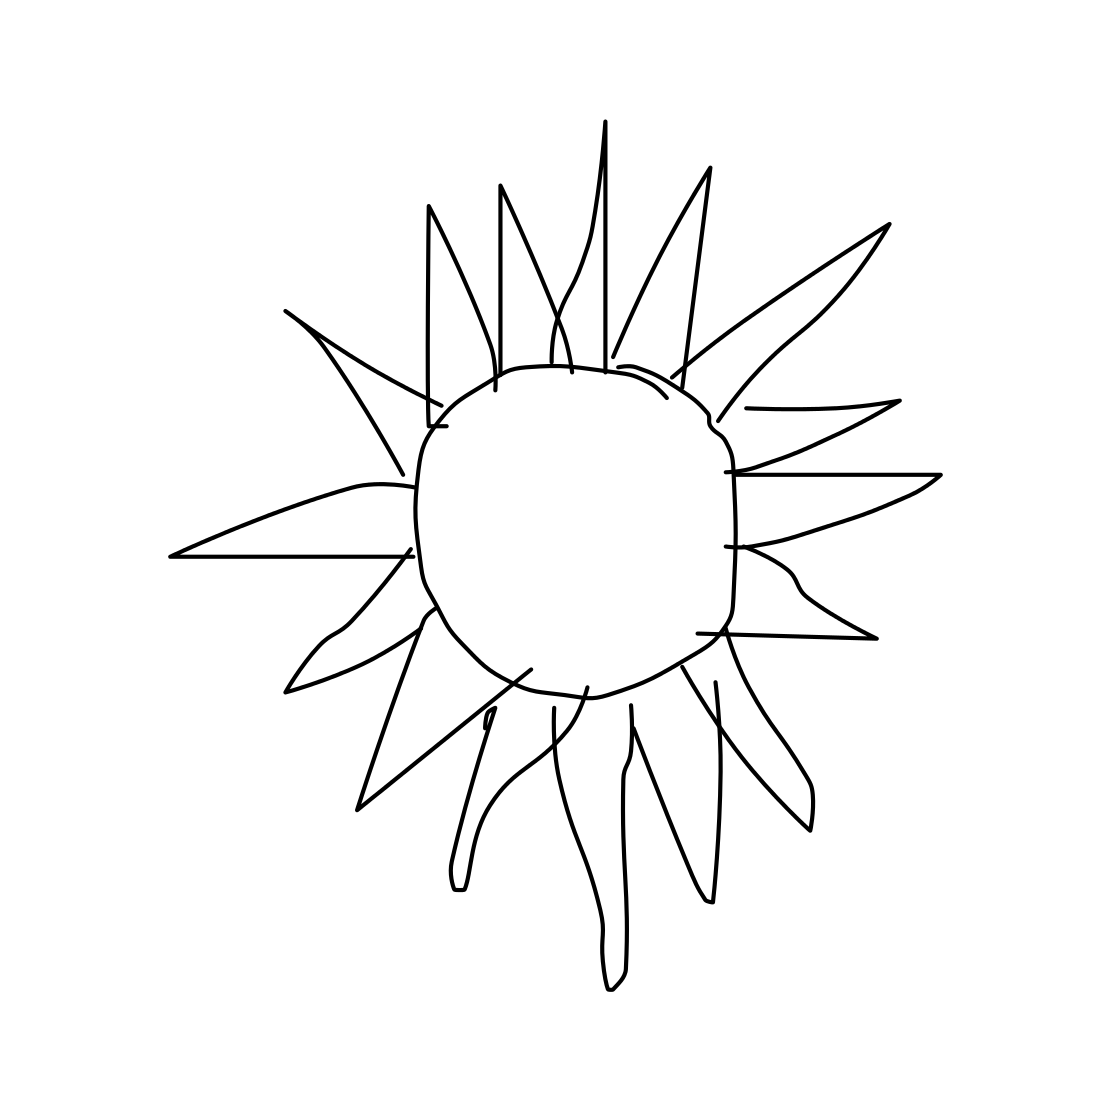What is the style of this drawing? This drawing exhibits a minimalist style, characterized by its basic line art and absence of intricate detailing. 